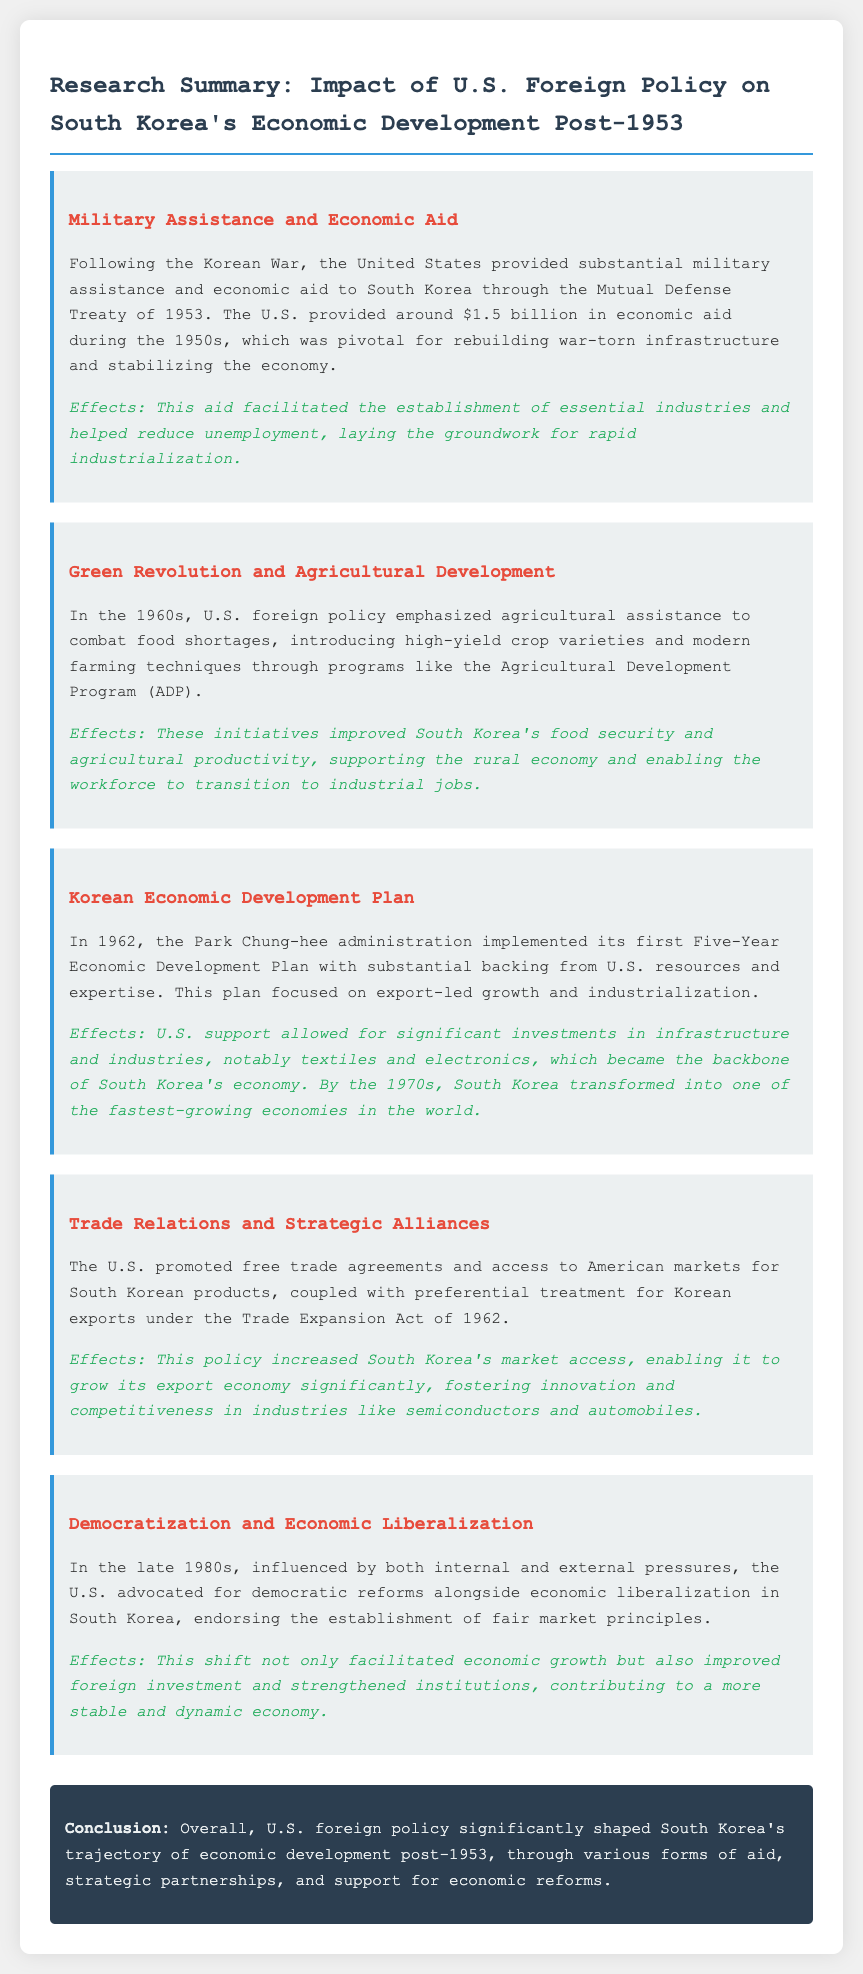What was the amount of economic aid provided by the U.S. in the 1950s? The document states that the U.S. provided around $1.5 billion in economic aid during the 1950s.
Answer: $1.5 billion What policy was implemented by the Park Chung-hee administration in 1962? The document mentions the first Five-Year Economic Development Plan was implemented in 1962.
Answer: Five-Year Economic Development Plan What agricultural program introduced high-yield crop varieties in the 1960s? The document refers to the Agricultural Development Program (ADP) as the initiative that introduced high-yield crop varieties.
Answer: Agricultural Development Program (ADP) What was emphasized alongside economic liberalization in the late 1980s? The document highlights that democratization was advocated alongside economic liberalization during this period.
Answer: Democratization What key industries were supported by U.S. resources according to the Korean Economic Development Plan? The plan allowed for significant investments in industries, notably textiles and electronics.
Answer: Textiles and electronics What act provided preferential treatment for Korean exports? The document states that the Trade Expansion Act of 1962 provided preferential treatment for Korean exports.
Answer: Trade Expansion Act of 1962 What was a principal effect of U.S. military assistance to South Korea? The document explains that military assistance and economic aid helped reduce unemployment and establish essential industries.
Answer: Reduced unemployment What did the U.S. policy on trade relations help to grow in South Korea? The policy increased South Korea's market access and fostered growth in its export economy.
Answer: Export economy What conclusion is drawn about U.S. foreign policy's impact on South Korea's economy? The conclusion states that U.S. foreign policy significantly shaped South Korea's trajectory of economic development post-1953.
Answer: Significantly shaped South Korea's trajectory 